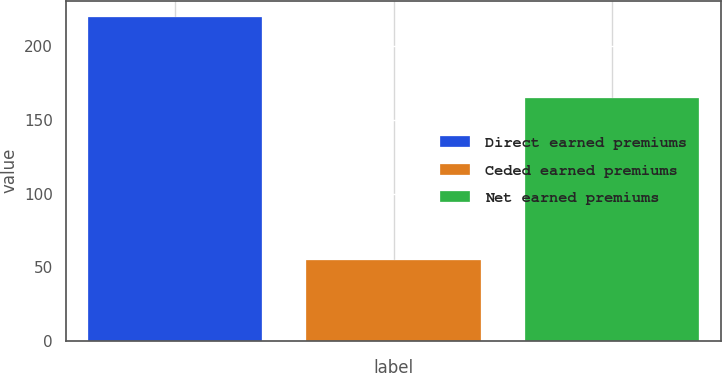<chart> <loc_0><loc_0><loc_500><loc_500><bar_chart><fcel>Direct earned premiums<fcel>Ceded earned premiums<fcel>Net earned premiums<nl><fcel>220<fcel>55<fcel>165<nl></chart> 